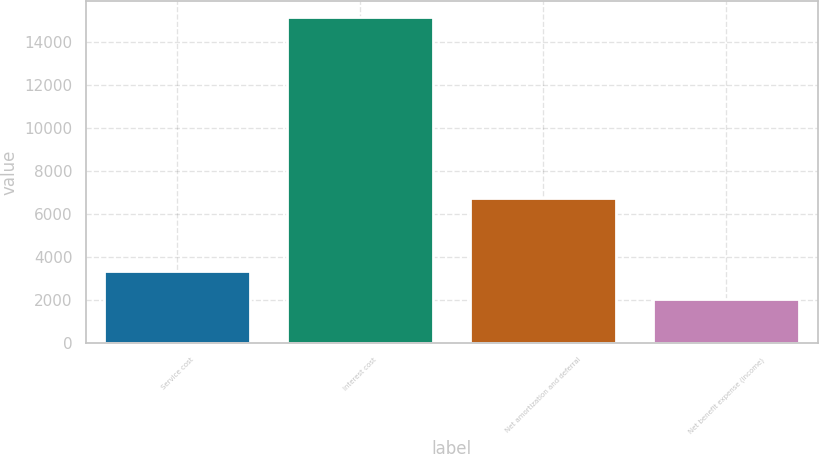Convert chart. <chart><loc_0><loc_0><loc_500><loc_500><bar_chart><fcel>Service cost<fcel>Interest cost<fcel>Net amortization and deferral<fcel>Net benefit expense (income)<nl><fcel>3359.6<fcel>15137<fcel>6734<fcel>2051<nl></chart> 